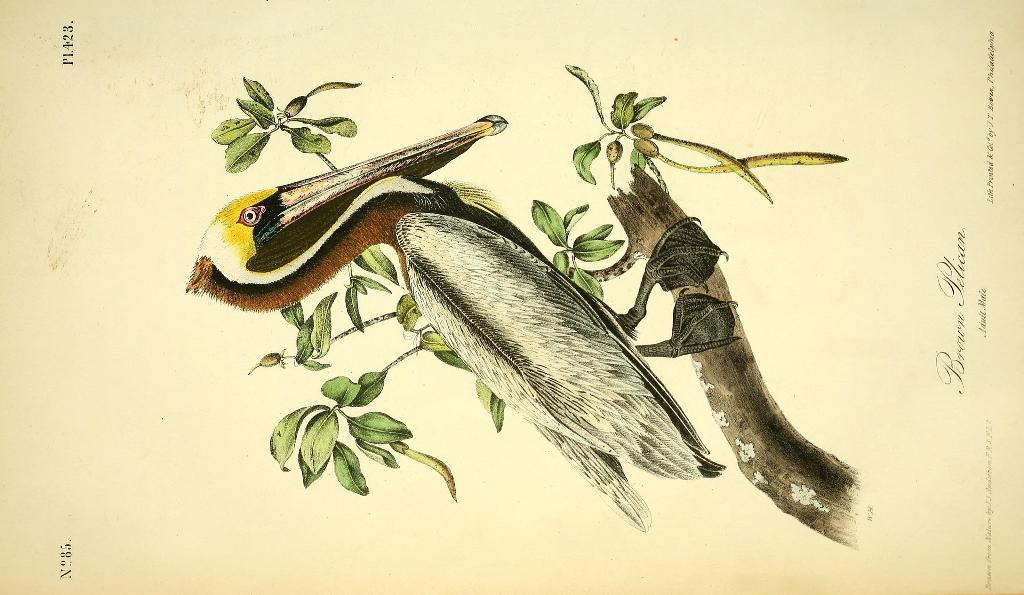What is the main subject of the paper in the image? The paper contains a sketch of a bird. What other elements are included in the sketch on the paper? Leaves and a branch of a tree are shown on the paper. Is there any text present on the paper in the image? Yes, there is text on the right side of the paper in the image. How does the heart shape fit into the sketch of the bird on the paper? There is no heart shape present in the sketch of the bird on the paper. What type of cracker is shown being eaten by the bird in the image? There is no cracker depicted in the image; the sketch is of a bird with leaves and a branch of a tree. 